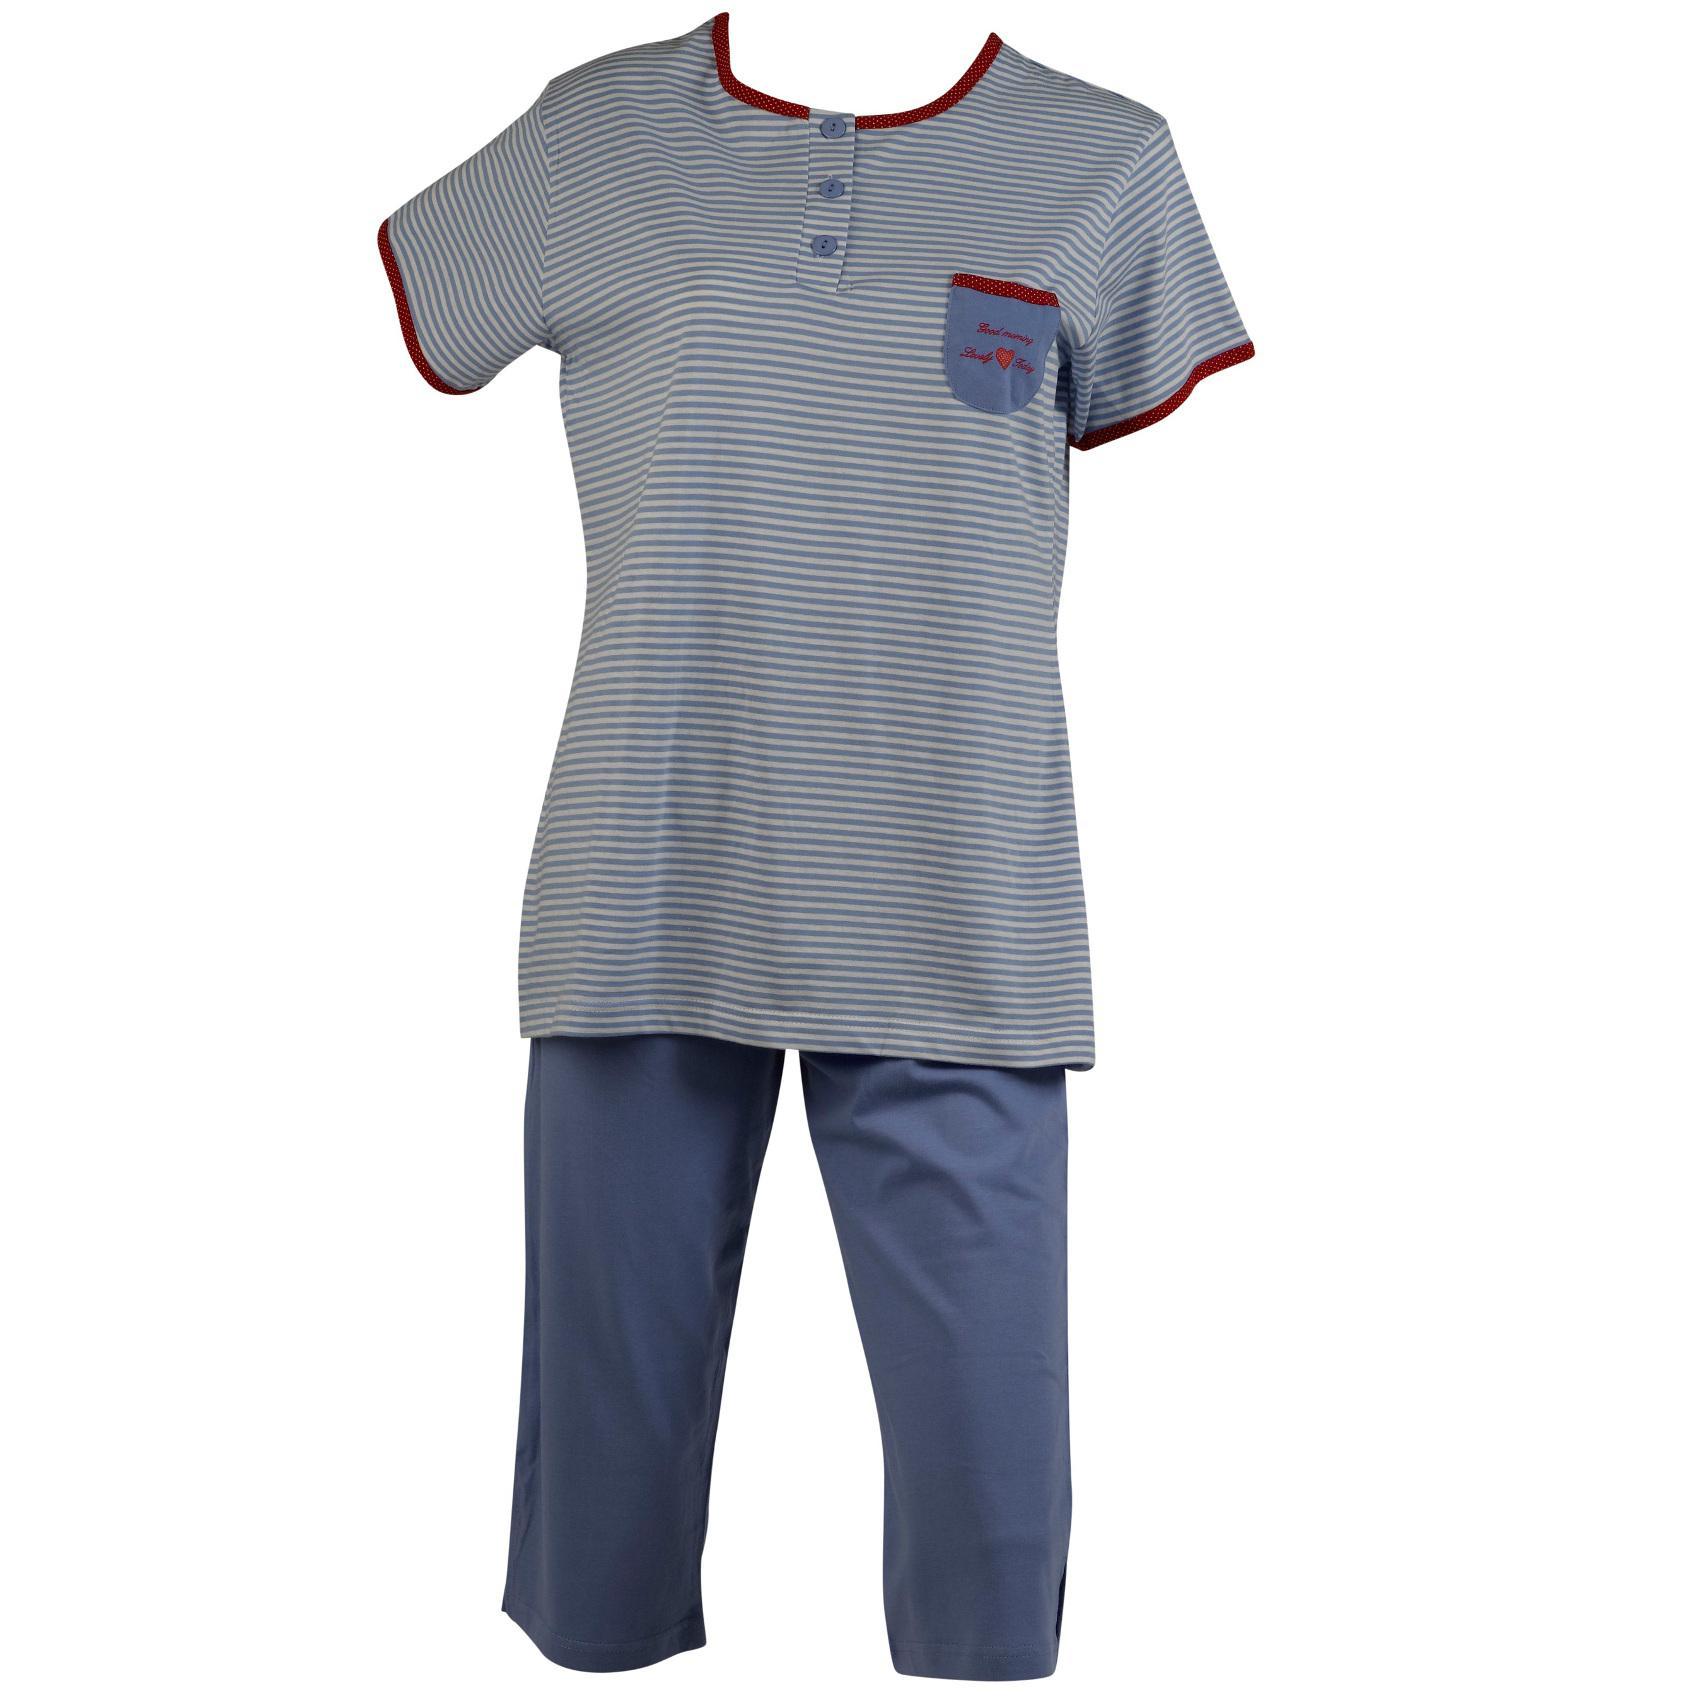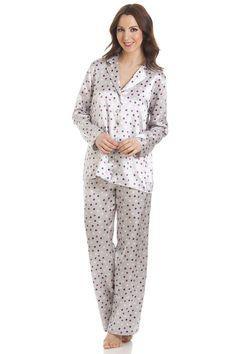The first image is the image on the left, the second image is the image on the right. For the images displayed, is the sentence "At least one pair of pajamas are polka-dotted." factually correct? Answer yes or no. Yes. 